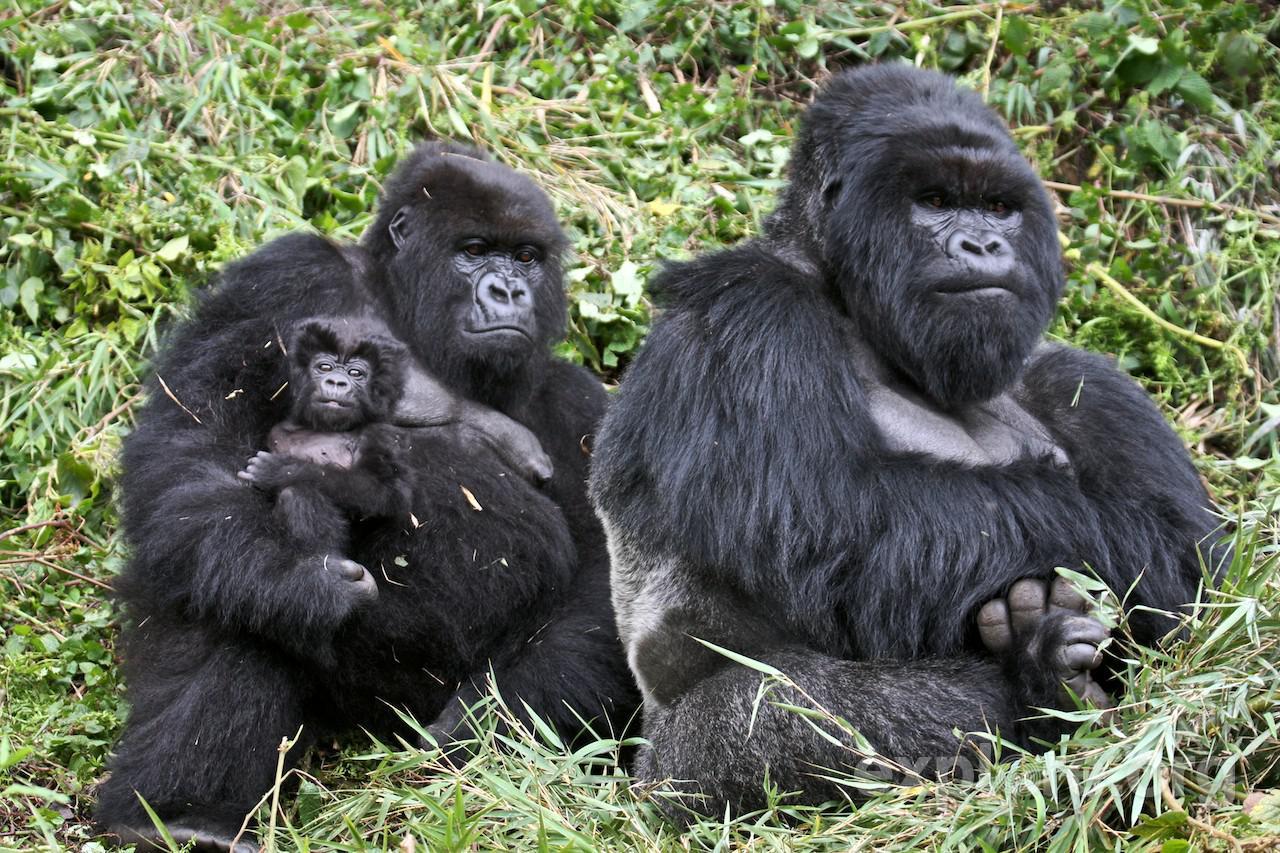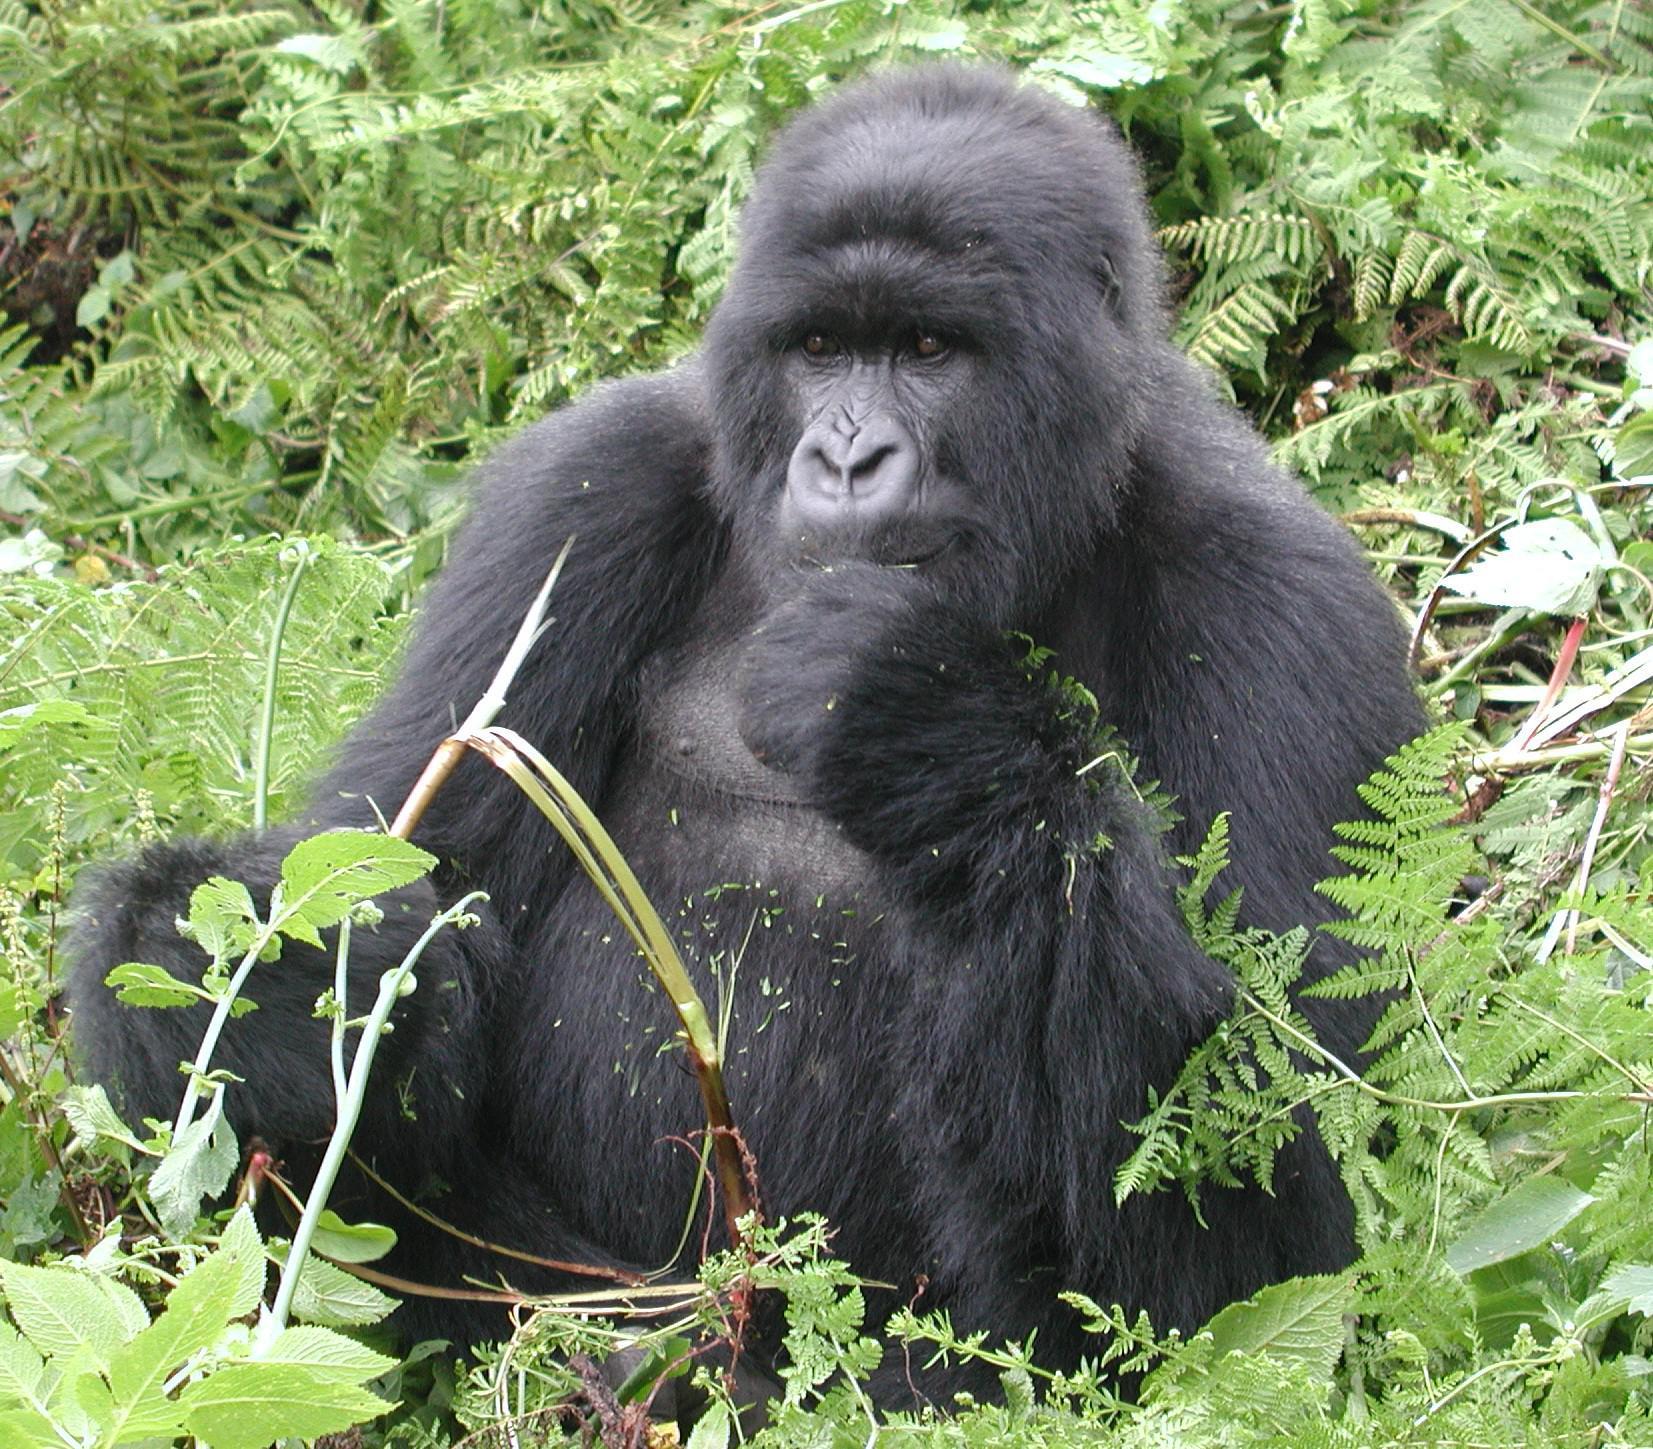The first image is the image on the left, the second image is the image on the right. Analyze the images presented: Is the assertion "In total, the images depict at least four black-haired apes." valid? Answer yes or no. Yes. 